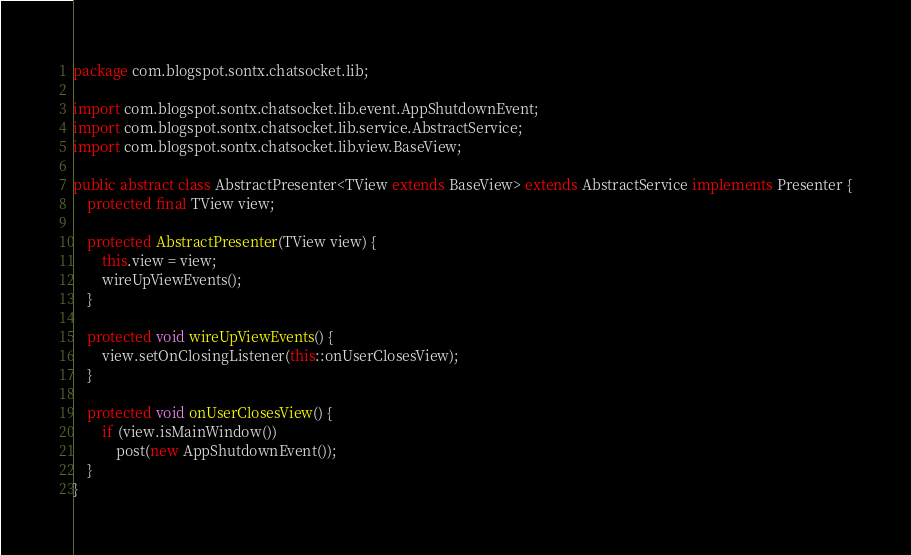<code> <loc_0><loc_0><loc_500><loc_500><_Java_>package com.blogspot.sontx.chatsocket.lib;

import com.blogspot.sontx.chatsocket.lib.event.AppShutdownEvent;
import com.blogspot.sontx.chatsocket.lib.service.AbstractService;
import com.blogspot.sontx.chatsocket.lib.view.BaseView;

public abstract class AbstractPresenter<TView extends BaseView> extends AbstractService implements Presenter {
    protected final TView view;

    protected AbstractPresenter(TView view) {
        this.view = view;
        wireUpViewEvents();
    }

    protected void wireUpViewEvents() {
        view.setOnClosingListener(this::onUserClosesView);
    }

    protected void onUserClosesView() {
        if (view.isMainWindow())
            post(new AppShutdownEvent());
    }
}
</code> 